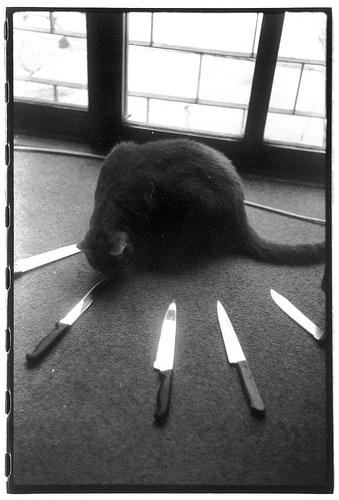What is the cat near? knives 